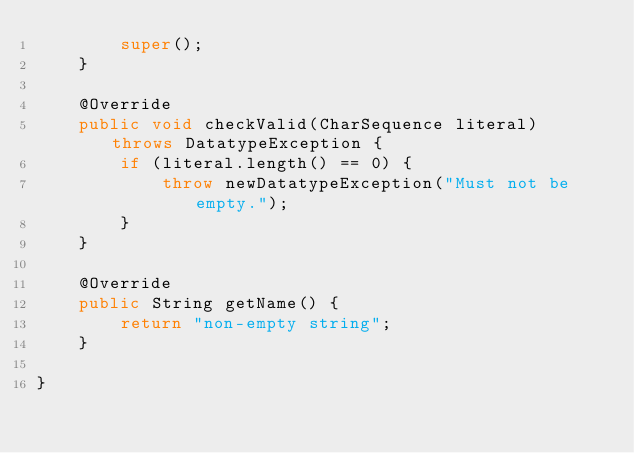Convert code to text. <code><loc_0><loc_0><loc_500><loc_500><_Java_>        super();
    }

    @Override
    public void checkValid(CharSequence literal) throws DatatypeException {
        if (literal.length() == 0) {
            throw newDatatypeException("Must not be empty.");
        }
    }

    @Override
    public String getName() {
        return "non-empty string";
    }

}
</code> 